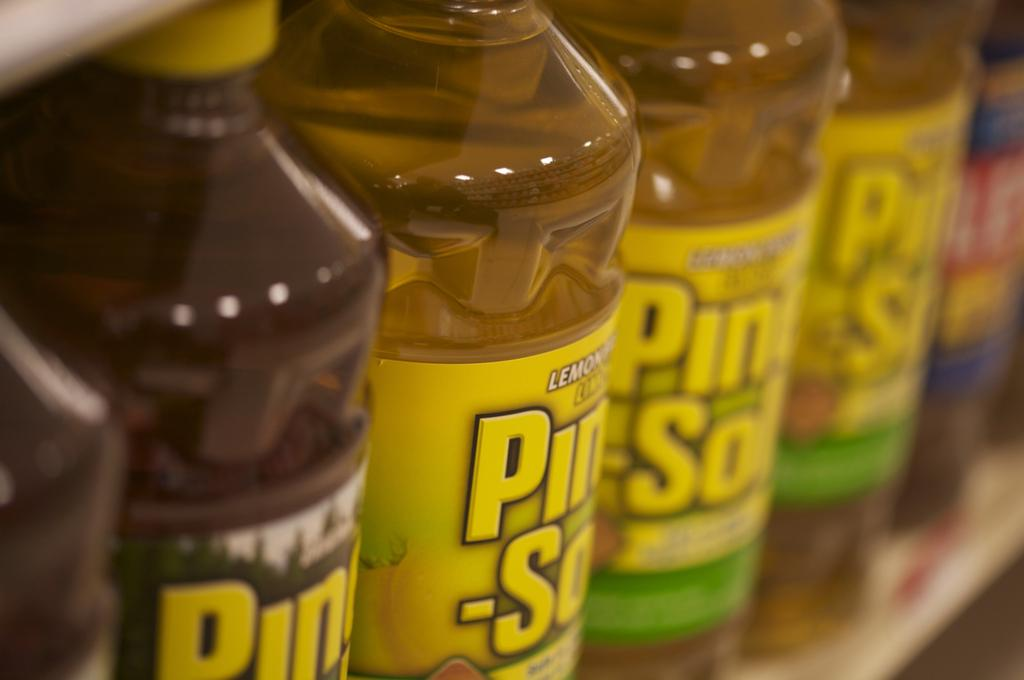<image>
Summarize the visual content of the image. a row of pine-sol bottles next to each other on a shelf 